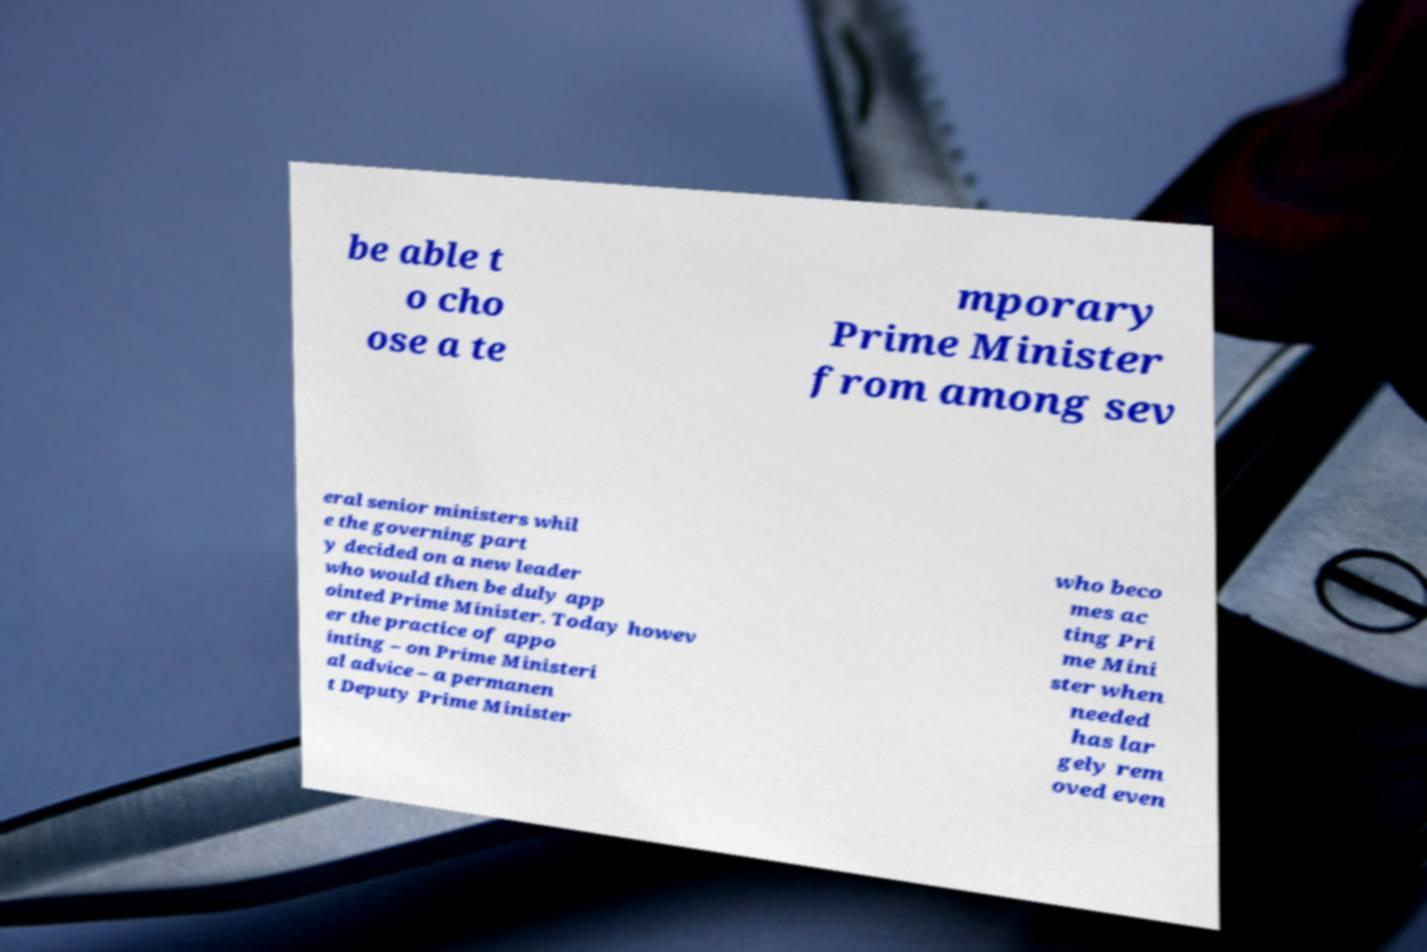What messages or text are displayed in this image? I need them in a readable, typed format. be able t o cho ose a te mporary Prime Minister from among sev eral senior ministers whil e the governing part y decided on a new leader who would then be duly app ointed Prime Minister. Today howev er the practice of appo inting – on Prime Ministeri al advice – a permanen t Deputy Prime Minister who beco mes ac ting Pri me Mini ster when needed has lar gely rem oved even 